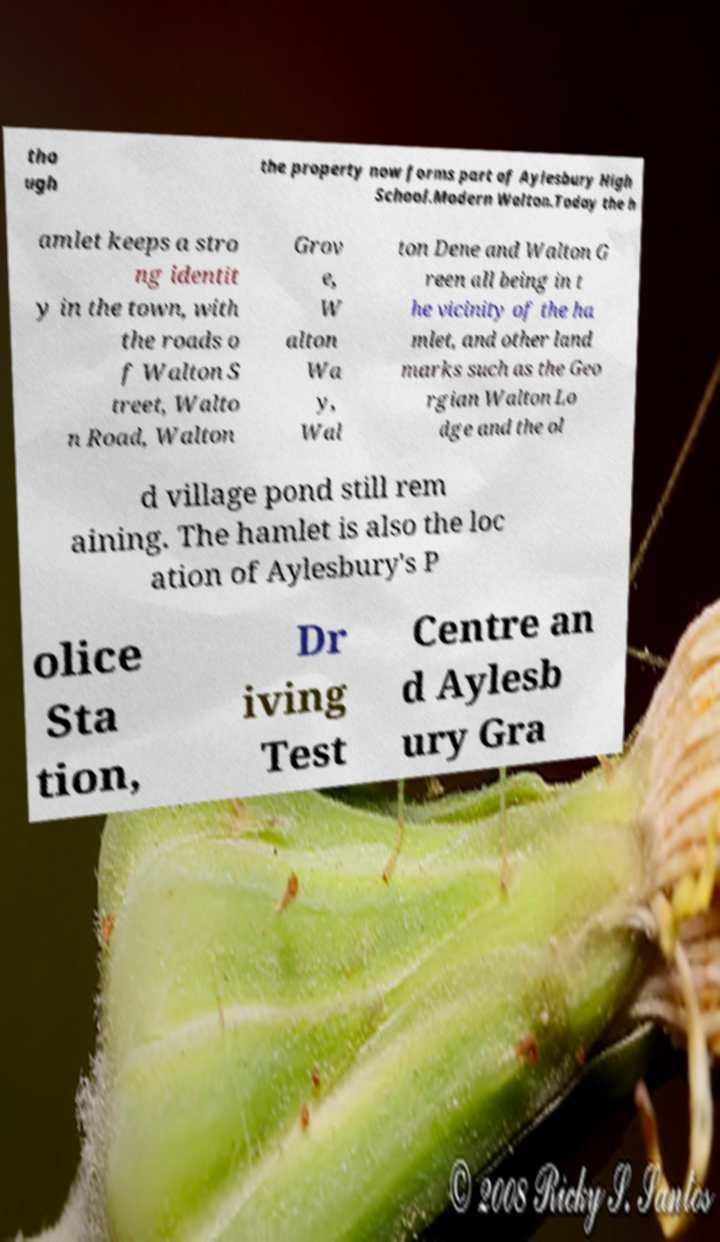Please read and relay the text visible in this image. What does it say? tho ugh the property now forms part of Aylesbury High School.Modern Walton.Today the h amlet keeps a stro ng identit y in the town, with the roads o f Walton S treet, Walto n Road, Walton Grov e, W alton Wa y, Wal ton Dene and Walton G reen all being in t he vicinity of the ha mlet, and other land marks such as the Geo rgian Walton Lo dge and the ol d village pond still rem aining. The hamlet is also the loc ation of Aylesbury's P olice Sta tion, Dr iving Test Centre an d Aylesb ury Gra 